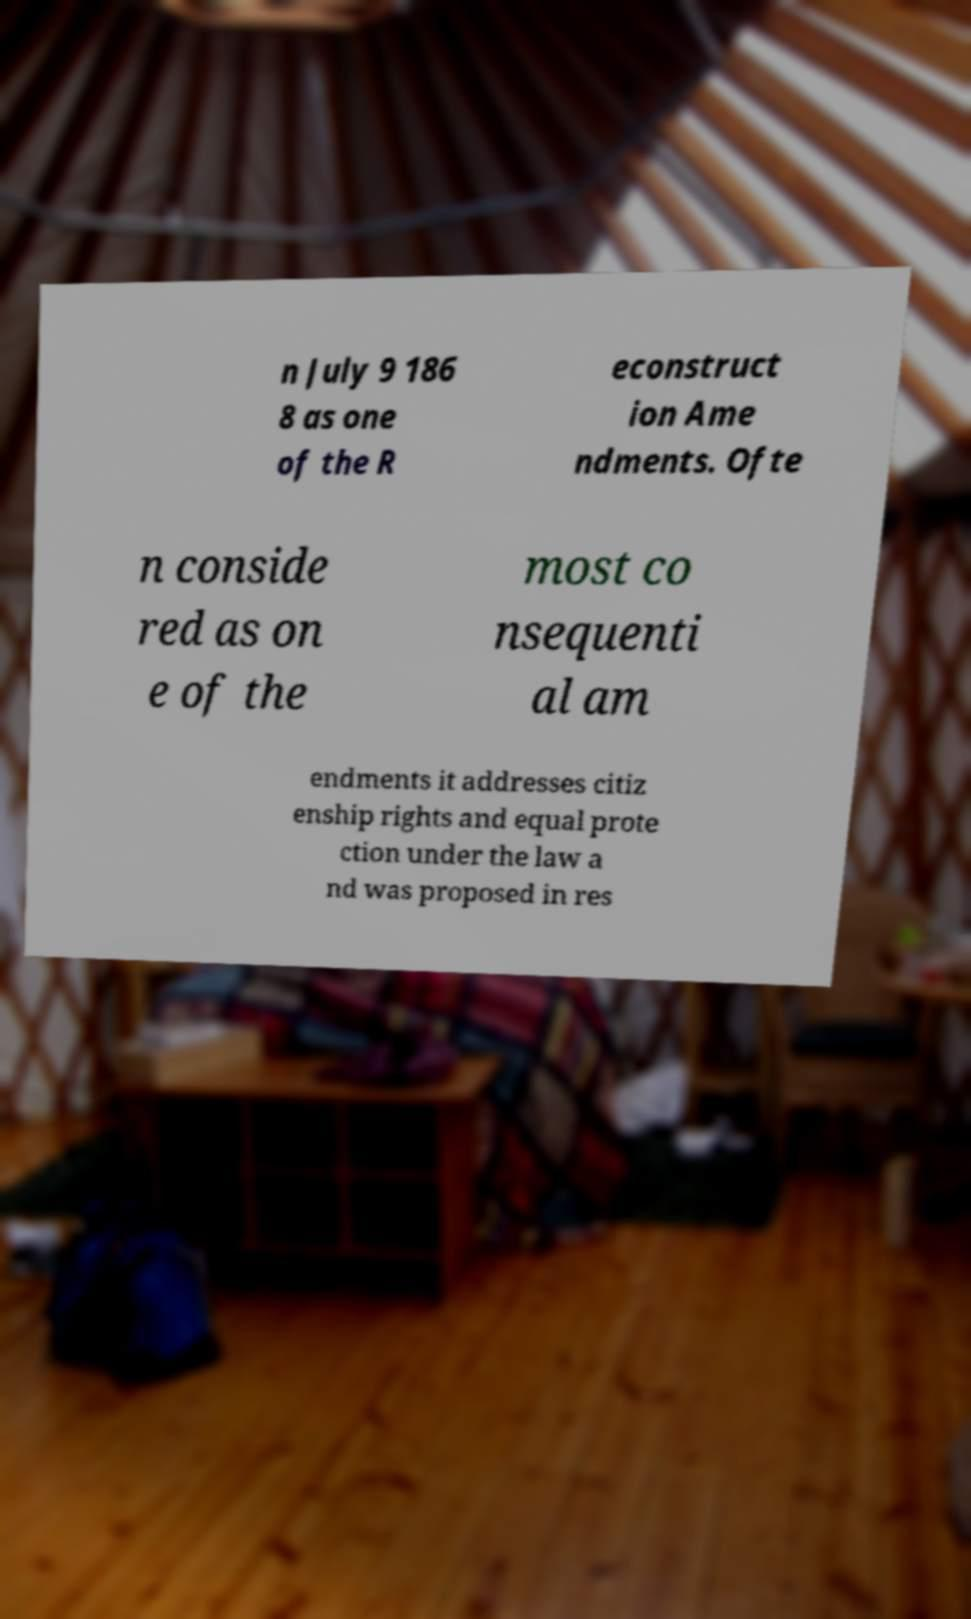Could you assist in decoding the text presented in this image and type it out clearly? n July 9 186 8 as one of the R econstruct ion Ame ndments. Ofte n conside red as on e of the most co nsequenti al am endments it addresses citiz enship rights and equal prote ction under the law a nd was proposed in res 